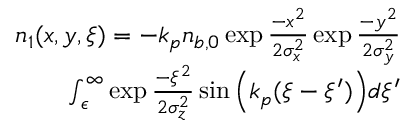<formula> <loc_0><loc_0><loc_500><loc_500>\begin{array} { r } { n _ { 1 } ( x , y , \xi ) = - k _ { p } n _ { b , 0 } \exp { \frac { - x ^ { 2 } } { 2 \sigma _ { x } ^ { 2 } } } \exp { \frac { - y ^ { 2 } } { 2 \sigma _ { y } ^ { 2 } } } } \\ { \int _ { \epsilon } ^ { \infty } \exp { \frac { - \xi ^ { 2 } } { 2 \sigma _ { z } ^ { 2 } } } \sin { \left ( k _ { p } ( \xi - \xi ^ { \prime } ) \right ) } d \xi ^ { \prime } } \end{array}</formula> 